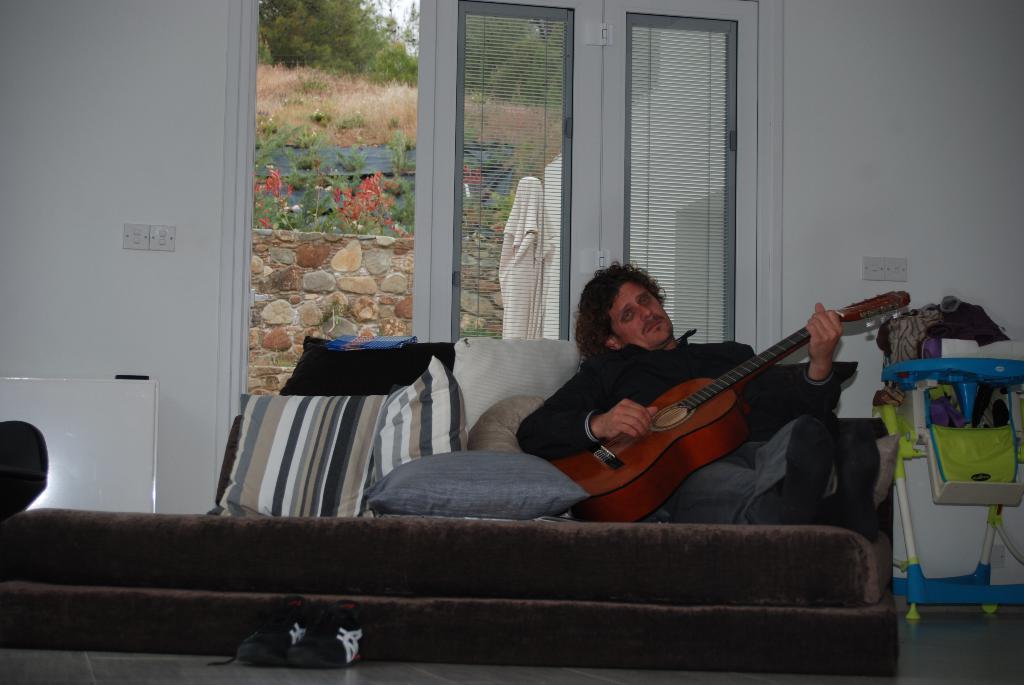Can you describe this image briefly? In this picture we can see a man who is sitting on the bed. He is playing guitar. These are the pillows. On the background there is a wall. This is the door. Even we can see some trees here. And these are the shoes and this is floor. 